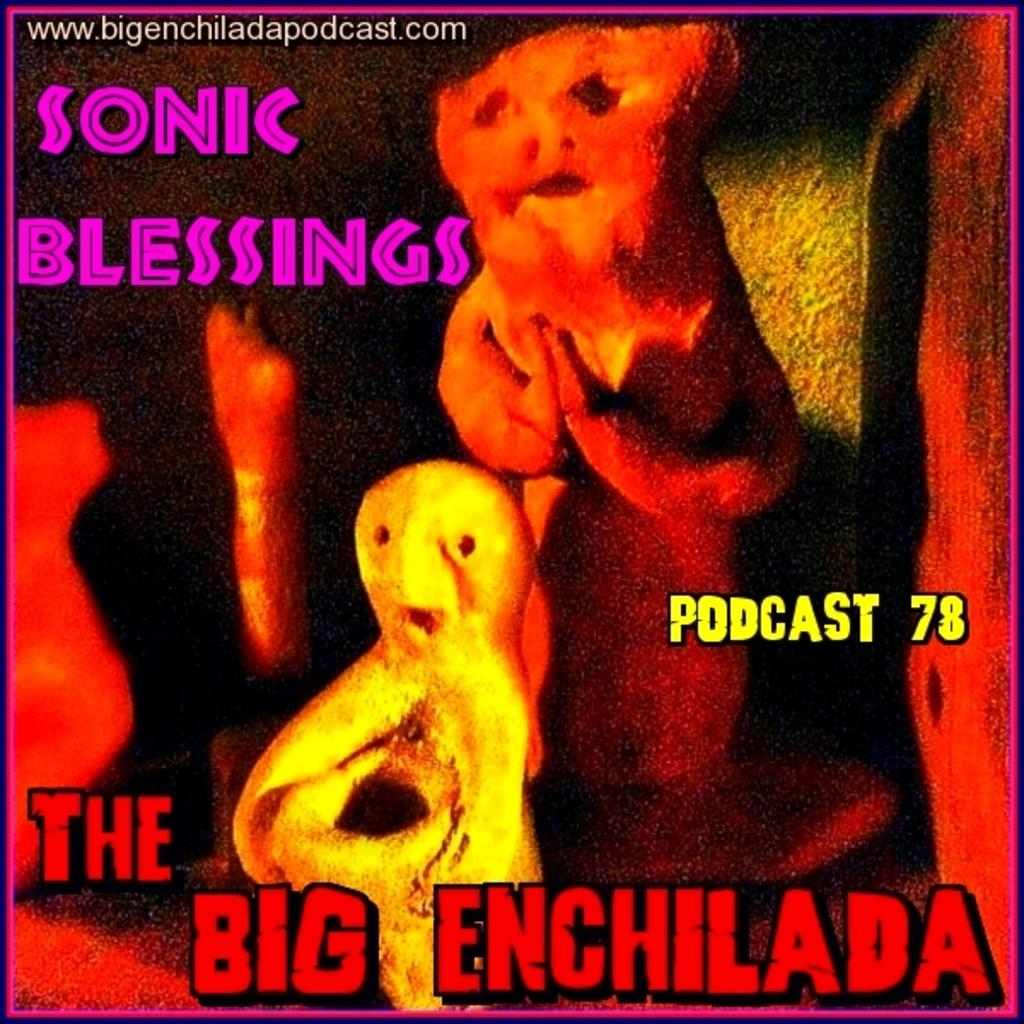Provide a one-sentence caption for the provided image. a sign with the words the big enchilada. 